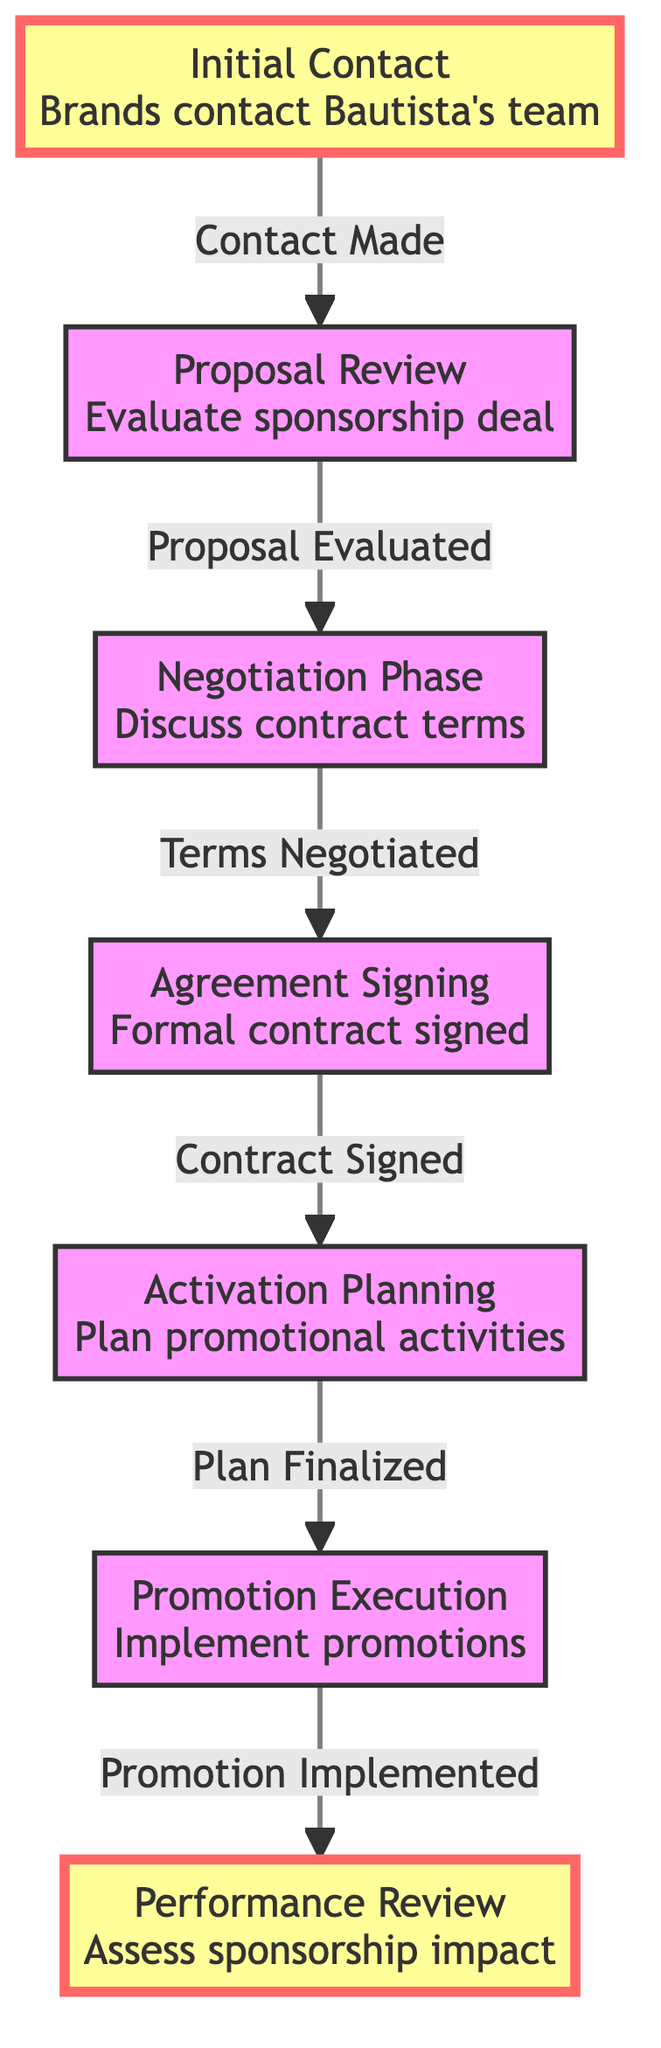What is the first step in the sponsorship flow? The first node in the diagram is "Initial Contact," which represents the starting point of the sponsorship process.
Answer: Initial Contact How many nodes are there in the diagram? By counting each unique step in the diagram, we identify a total of seven nodes (steps).
Answer: 7 What do Álvaro Bautista's team evaluate in the second step? The second node is "Proposal Review," where Bautista and his management evaluate the sponsorship deal proposals they receive.
Answer: Sponsorship deal Which step comes after the "Negotiation Phase"? Following the "Negotiation Phase," which focuses on discussing contract terms, the next step is "Agreement Signing."
Answer: Agreement Signing What type of activities are planned during "Activation Planning"? The "Activation Planning" step involves planning promotional activities such as social media posts, commercials, and race branding.
Answer: Promotional activities How does "Promotion Execution" relate to "Performance Review"? "Promotion Execution" is the step where promotional implementations occur, while "Performance Review" assesses their impact; thus, "Promotion Execution" leads into "Performance Review."
Answer: Implementation leads to performance assessment What is the relationship between nodes 3 and 4? Node 3 ("Negotiation Phase") leads to node 4 ("Agreement Signing") with the label "Terms Negotiated," indicating the negotiation's conclusion results in a signed agreement.
Answer: Terms Negotiated Which node highlights the end of the sponsorship evaluation? The final node, "Performance Review," highlights the conclusion of evaluating the sponsorship's effectiveness, marking the end of the process.
Answer: Performance Review 